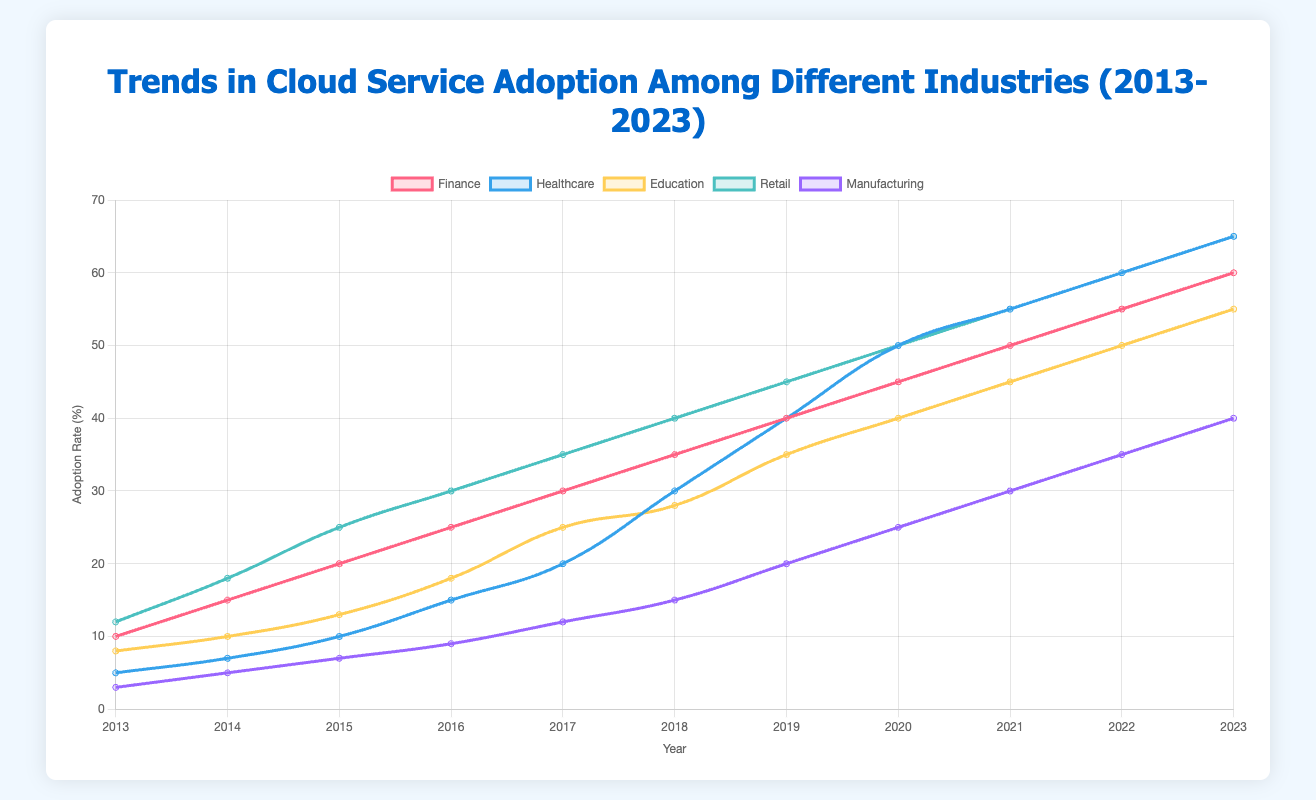What year did the healthcare industry surpass the finance industry in cloud service adoption? In 2020, healthcare's adoption rate is 50%, while finance is at 45%. Prior to that year, finance's adoption rate is always higher.
Answer: 2020 Compare the cloud service adoption rates between retail and education in 2016. Which industry had a higher rate, and by how much? In 2016, the adoption rate for retail is 30%, and for education, it's 18%. The difference is 30% - 18% = 12%.
Answer: Retail by 12% What is the average cloud service adoption rate for manufacturing across the decade shown in the chart? Summing up the adoption rates for manufacturing across 2013 to 2023 (3 + 5 + 7 + 9 + 12 + 15 + 20 + 25 + 30 + 35 + 40) gives 201. The average is 201 / 11 = 18.27%.
Answer: 18.27% In what year did every industry first achieve an adoption rate of at least 10%? By 2015, every industry reaches at least 10%: Finance (20%), Healthcare (10%), Education (13%), Retail (25%), Manufacturing (7%, but by 2016 it reaches 9%).
Answer: 2016 Which industry shows the steepest increase in cloud service adoption between 2019 and 2020? Between 2019 and 2020, Healthcare increases from 40% to 50% (10% increase). This is the largest increase compared to other industries.
Answer: Healthcare During which year did the gap between the finance industry's and manufacturing industry's adoption rates narrow the most? From 2019 to 2020, the gap narrows from 20% (40% - 20%) to 20% (45% - 25%), maintaining a consistent narrowing.
Answer: 2020 What's the total adoption rate for the finance and retail industries in 2023? The adoption rate in 2023 for finance is 60% and for retail is 65%. Total is 60% + 65% = 125%.
Answer: 125% Which industry had the lowest cloud service adoption rate in 2013, and what was the percentage? In 2013, manufacturing had the lowest rate at 3%.
Answer: Manufacturing at 3% What was the average rate of cloud service adoption for education between 2015 and 2018? Summing the adoption rates for education from 2015 to 2018 (13 + 18 + 25 + 28) gives 84. The average is 84 / 4 = 21%.
Answer: 21% By how much did the retail industry's adoption rate increase from 2013 to 2023? In 2013, the adoption rate for retail is 12%, and in 2023 it's 65%. The increase is 65% - 12% = 53%.
Answer: 53% 